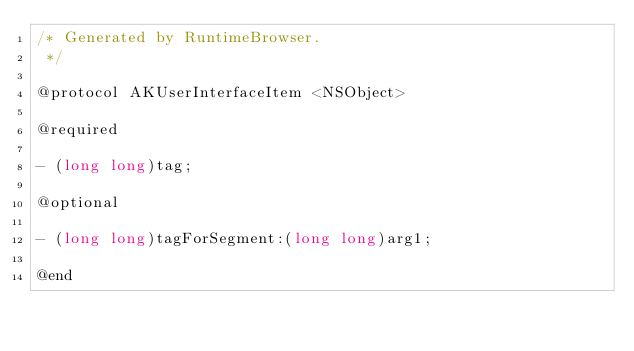<code> <loc_0><loc_0><loc_500><loc_500><_C_>/* Generated by RuntimeBrowser.
 */

@protocol AKUserInterfaceItem <NSObject>

@required

- (long long)tag;

@optional

- (long long)tagForSegment:(long long)arg1;

@end
</code> 